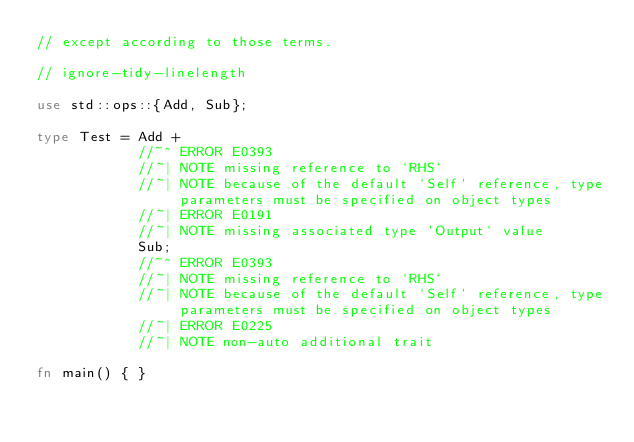<code> <loc_0><loc_0><loc_500><loc_500><_Rust_>// except according to those terms.

// ignore-tidy-linelength

use std::ops::{Add, Sub};

type Test = Add +
            //~^ ERROR E0393
            //~| NOTE missing reference to `RHS`
            //~| NOTE because of the default `Self` reference, type parameters must be specified on object types
            //~| ERROR E0191
            //~| NOTE missing associated type `Output` value
            Sub;
            //~^ ERROR E0393
            //~| NOTE missing reference to `RHS`
            //~| NOTE because of the default `Self` reference, type parameters must be specified on object types
            //~| ERROR E0225
            //~| NOTE non-auto additional trait

fn main() { }
</code> 